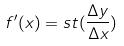Convert formula to latex. <formula><loc_0><loc_0><loc_500><loc_500>f ^ { \prime } ( x ) = s t ( \frac { \Delta y } { \Delta x } )</formula> 